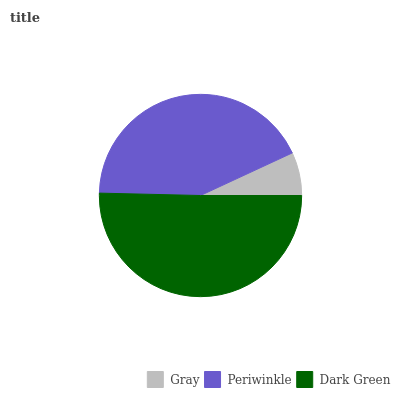Is Gray the minimum?
Answer yes or no. Yes. Is Dark Green the maximum?
Answer yes or no. Yes. Is Periwinkle the minimum?
Answer yes or no. No. Is Periwinkle the maximum?
Answer yes or no. No. Is Periwinkle greater than Gray?
Answer yes or no. Yes. Is Gray less than Periwinkle?
Answer yes or no. Yes. Is Gray greater than Periwinkle?
Answer yes or no. No. Is Periwinkle less than Gray?
Answer yes or no. No. Is Periwinkle the high median?
Answer yes or no. Yes. Is Periwinkle the low median?
Answer yes or no. Yes. Is Gray the high median?
Answer yes or no. No. Is Gray the low median?
Answer yes or no. No. 